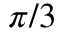<formula> <loc_0><loc_0><loc_500><loc_500>\pi / 3</formula> 